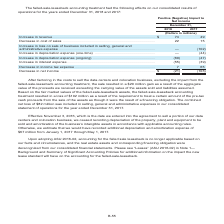According to Centurylink's financial document, What is the 2018 increase in revenue? According to the financial document, $74 (in millions). The relevant text states: "(Dollars in millions) Increase in revenue . $ 74 49 Decrease in cost of sales . 22 15 Increase in loss on sale of business included in selling, gene..." Also, Where was the combined net loss of $82 million reported in? in selling, general and administrative expenses in our consolidated statement of operations for the year ended December 31, 2017. The document states: "The combined net loss of $82 million was included in selling, general and administrative expenses in our consolidated statement of operations for the ..." Also, The table contains the consolidated results of operations for which years? The document shows two values: 2018 and 2017. From the document: "2018 2017 2018 2017..." Additionally, Which year had a larger decrease in the cost of sales? According to the financial document, 2018. The relevant text states: "2018 2017..." Also, can you calculate: What is the change in the increase in revenue in 2018 from 2017? Based on the calculation: $74-$49, the result is 25 (in millions). This is based on the information: "(Dollars in millions) Increase in revenue . $ 74 49 Decrease in cost of sales . 22 15 Increase in loss on sale of business included in selling, gene (Dollars in millions) Increase in revenue . $ 74 49..." The key data points involved are: 49, 74. Also, can you calculate: What is the average increase in revenue across 2017 and 2018? To answer this question, I need to perform calculations using the financial data. The calculation is: ($74+$49)/2, which equals 61.5 (in millions). This is based on the information: "(Dollars in millions) Increase in revenue . $ 74 49 Decrease in cost of sales . 22 15 Increase in loss on sale of business included in selling, gene (Dollars in millions) Increase in revenue . $ 74 49..." The key data points involved are: 49, 74. 